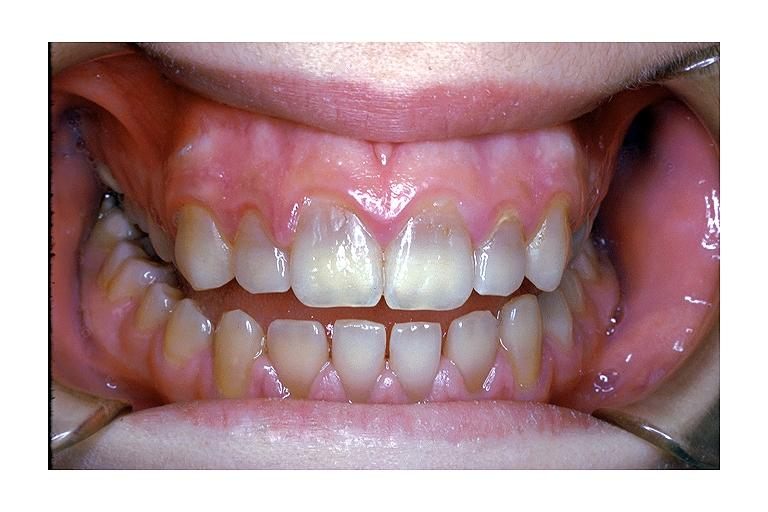where is this?
Answer the question using a single word or phrase. Oral 